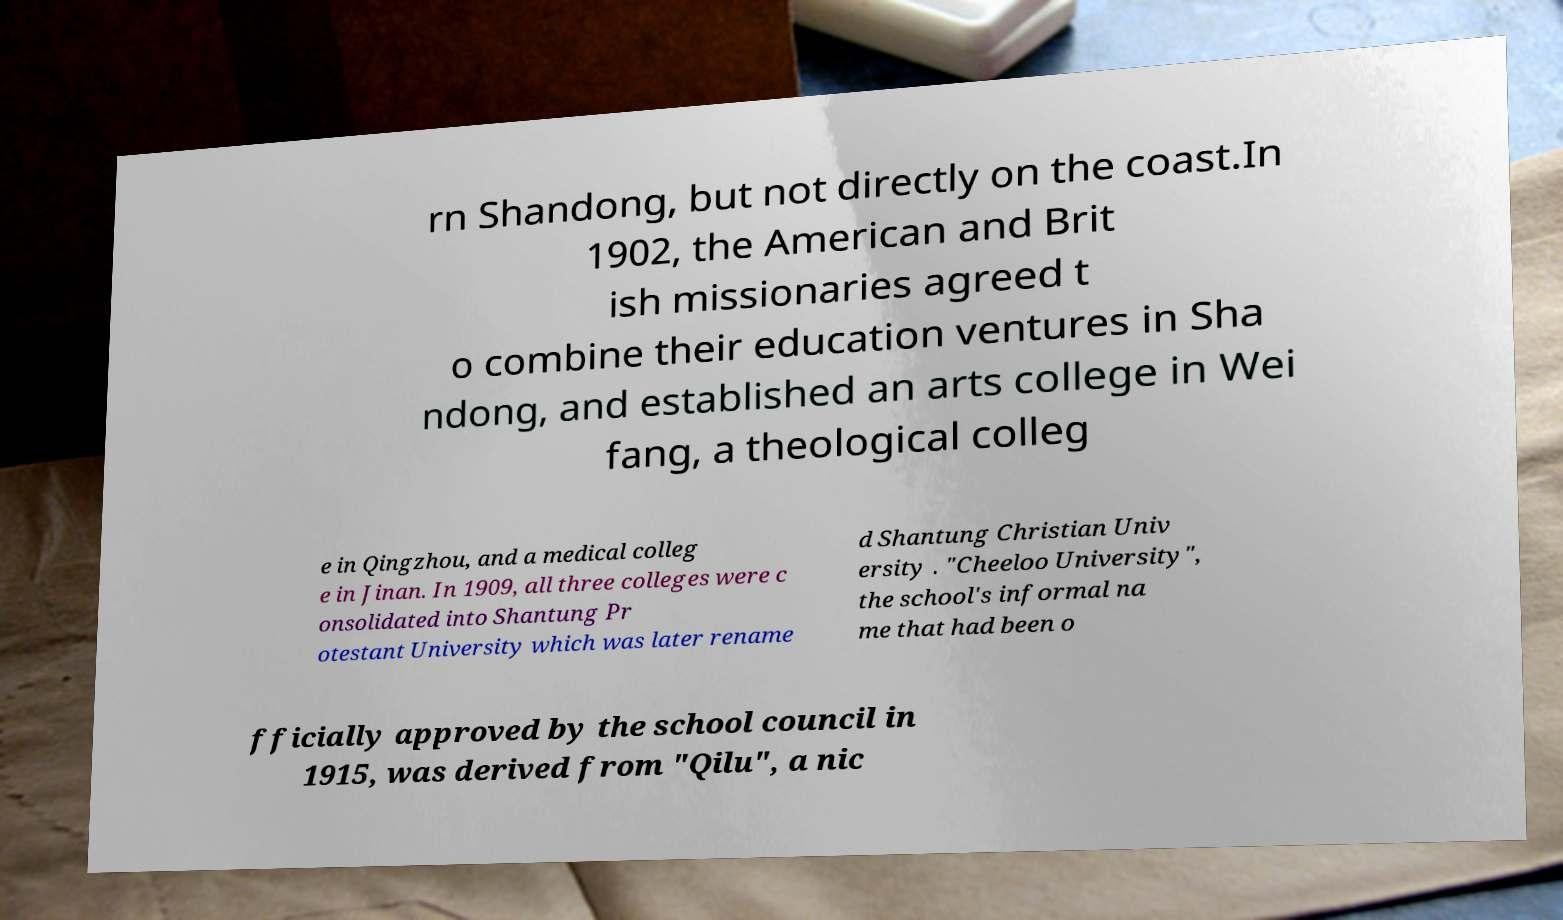I need the written content from this picture converted into text. Can you do that? rn Shandong, but not directly on the coast.In 1902, the American and Brit ish missionaries agreed t o combine their education ventures in Sha ndong, and established an arts college in Wei fang, a theological colleg e in Qingzhou, and a medical colleg e in Jinan. In 1909, all three colleges were c onsolidated into Shantung Pr otestant University which was later rename d Shantung Christian Univ ersity . "Cheeloo University", the school's informal na me that had been o fficially approved by the school council in 1915, was derived from "Qilu", a nic 